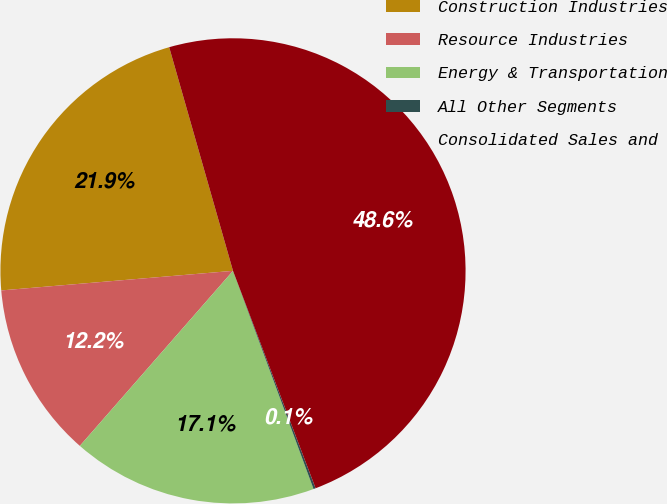<chart> <loc_0><loc_0><loc_500><loc_500><pie_chart><fcel>Construction Industries<fcel>Resource Industries<fcel>Energy & Transportation<fcel>All Other Segments<fcel>Consolidated Sales and<nl><fcel>21.92%<fcel>12.22%<fcel>17.07%<fcel>0.15%<fcel>48.65%<nl></chart> 